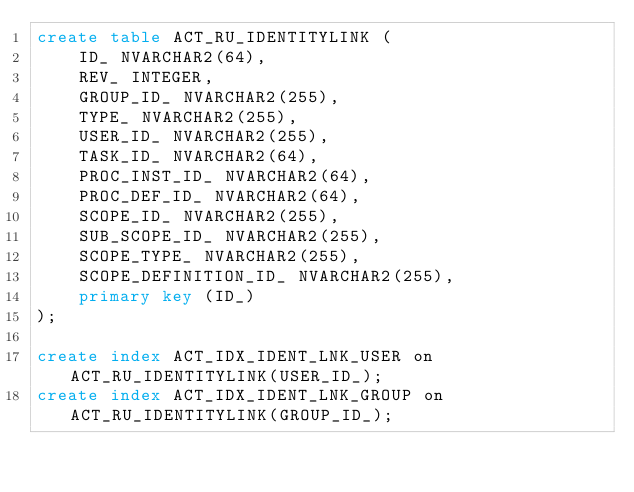<code> <loc_0><loc_0><loc_500><loc_500><_SQL_>create table ACT_RU_IDENTITYLINK (
    ID_ NVARCHAR2(64),
    REV_ INTEGER,
    GROUP_ID_ NVARCHAR2(255),
    TYPE_ NVARCHAR2(255),
    USER_ID_ NVARCHAR2(255),
    TASK_ID_ NVARCHAR2(64),
    PROC_INST_ID_ NVARCHAR2(64),
    PROC_DEF_ID_ NVARCHAR2(64),
    SCOPE_ID_ NVARCHAR2(255),
    SUB_SCOPE_ID_ NVARCHAR2(255),
    SCOPE_TYPE_ NVARCHAR2(255),
    SCOPE_DEFINITION_ID_ NVARCHAR2(255),
    primary key (ID_)
);

create index ACT_IDX_IDENT_LNK_USER on ACT_RU_IDENTITYLINK(USER_ID_);
create index ACT_IDX_IDENT_LNK_GROUP on ACT_RU_IDENTITYLINK(GROUP_ID_);</code> 